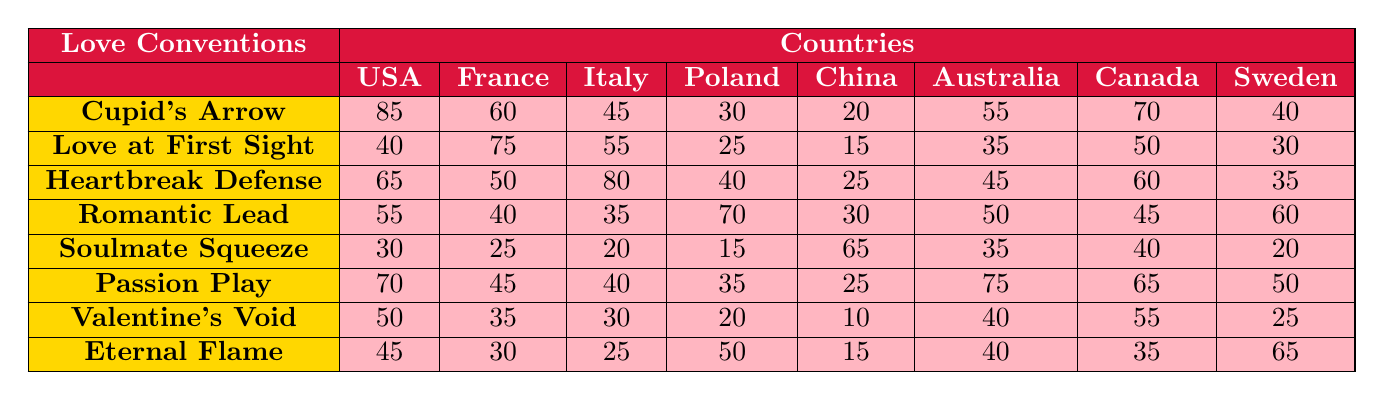What is the highest value of "Cupid's Arrow" across the countries? Looking at the row for "Cupid's Arrow," the highest value is found under the USA, which is 85.
Answer: 85 In which country is "Soulmate Squeeze" the most popular convention? The highest value for "Soulmate Squeeze" is in China, with a value of 65.
Answer: China What is the average value of "Heartbreak Defense" across all countries? To find the average, sum the values (65 + 50 + 80 + 40 + 25 + 45 + 60 + 35) = 400, and divide by 8 for the number of countries: 400/8 = 50.
Answer: 50 Is "Eternal Flame" equally popular in the USA and Italy? Checking the values for "Eternal Flame," the USA has a score of 45 while Italy has a score of 25, which are not equal.
Answer: No Which country has the lowest value for "Valentine's Void"? The lowest value for "Valentine's Void" is 10, which corresponds to China.
Answer: China What is the difference in popularity between "Love at First Sight" in France and Canada? The value for France is 75 and for Canada is 50. The difference is 75 - 50 = 25.
Answer: 25 What is the total popularity score for all countries under "Passion Play"? The total is calculated by summing the values (70 + 45 + 40 + 35 + 25 + 75 + 65 + 50) = 405.
Answer: 405 Which love convention shows the most consistent popularity across the countries? The values for "Romantic Lead" vary more significantly (range of 40), while others show greater variability. Analyzing the data, none shows strong consistency.
Answer: None What is the ranking of the USA in "Heartbreak Defense" compared to the other countries? The USA ranks third in "Heartbreak Defense" with a score of 65, as the highest scores are from Italy (80) and France (50).
Answer: 3rd Which two conventions are the least popular in Canada? For Canada, the lowest values are for "Soulmate Squeeze" (40) and "Valentine's Void" (55).
Answer: Soulmate Squeeze and Valentine's Void 